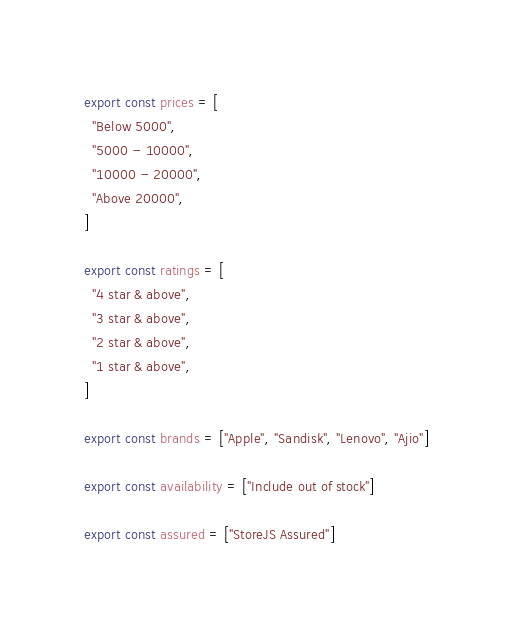<code> <loc_0><loc_0><loc_500><loc_500><_JavaScript_>export const prices = [
  "Below 5000",
  "5000 - 10000",
  "10000 - 20000",
  "Above 20000",
]

export const ratings = [
  "4 star & above",
  "3 star & above",
  "2 star & above",
  "1 star & above",
]

export const brands = ["Apple", "Sandisk", "Lenovo", "Ajio"]

export const availability = ["Include out of stock"]

export const assured = ["StoreJS Assured"]
</code> 